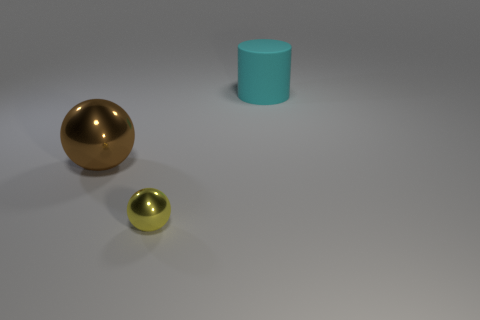Add 2 large brown rubber objects. How many objects exist? 5 Subtract all cylinders. How many objects are left? 2 Add 2 small blue metal spheres. How many small blue metal spheres exist? 2 Subtract 0 blue cylinders. How many objects are left? 3 Subtract all yellow shiny balls. Subtract all yellow balls. How many objects are left? 1 Add 2 big brown spheres. How many big brown spheres are left? 3 